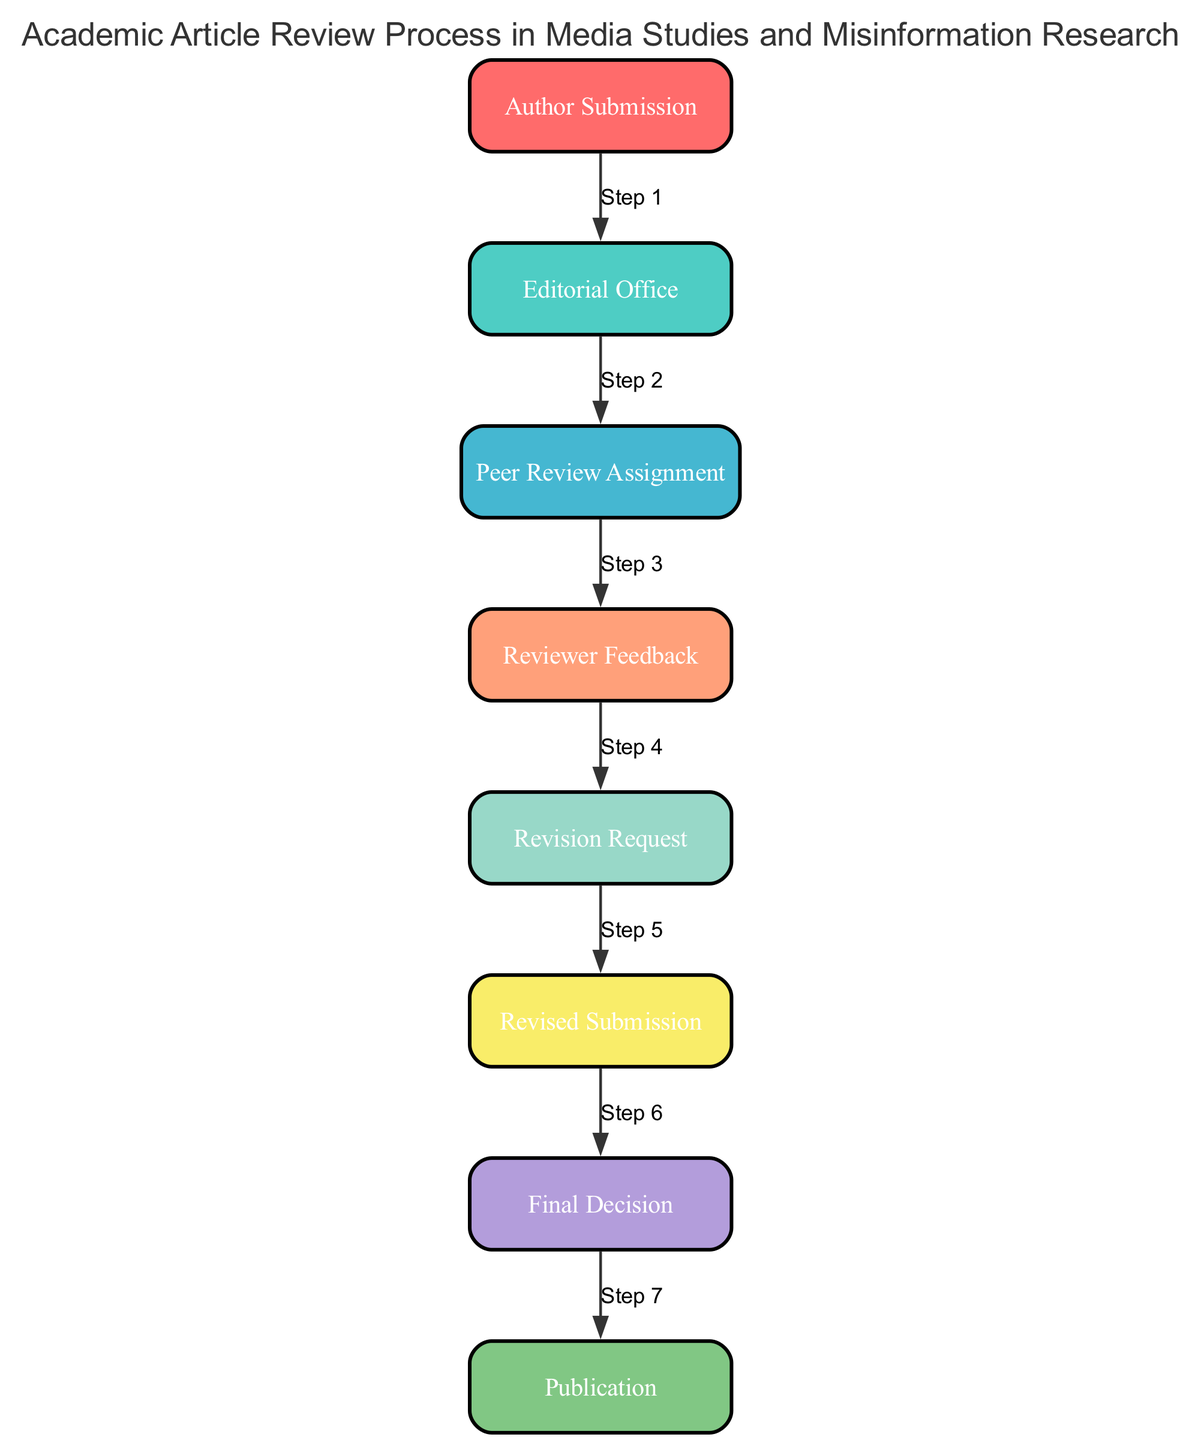What is the first step in the review process? The first step is "Author Submission," where the author submits their manuscript to the journal.
Answer: Author Submission How many total steps are there in the review process? The diagram clearly shows there are eight steps in the review process, from "Author Submission" to "Publication."
Answer: 8 What action follows the "Reviewer Feedback"? After "Reviewer Feedback," the next step is "Revision Request," where the editorial office communicates the feedback to the author.
Answer: Revision Request Which element represents the final outcome of the review process? The last element in the sequence is "Publication," indicating the accepted article is processed for publication in the journal.
Answer: Publication What is the relationship between "Editorial Office" and "Peer Review Assignment"? The "Editorial Office" initiates the "Peer Review Assignment," which involves selecting experts to review the manuscript.
Answer: The Editorial Office initiates the assignment What step comes immediately after the "Revised Submission"? Following the "Revised Submission," the next step is "Final Decision," where the editorial office reviews the revisions made by the author.
Answer: Final Decision What is the purpose of the "Revision Request"? The "Revision Request" is meant to convey the feedback from the peer reviewers back to the author with suggestions for improvement.
Answer: Convey feedback How many feedback discussions are involved before the final decision? There is one feedback discussion, which occurs between the "Reviewer Feedback" and the "Revision Request" steps before the final decision is made.
Answer: One What does the "Final Decision" depend on? The "Final Decision" is based on the revisions provided by the author and the feedback from the reviewers during the review process.
Answer: Revisions and feedback 